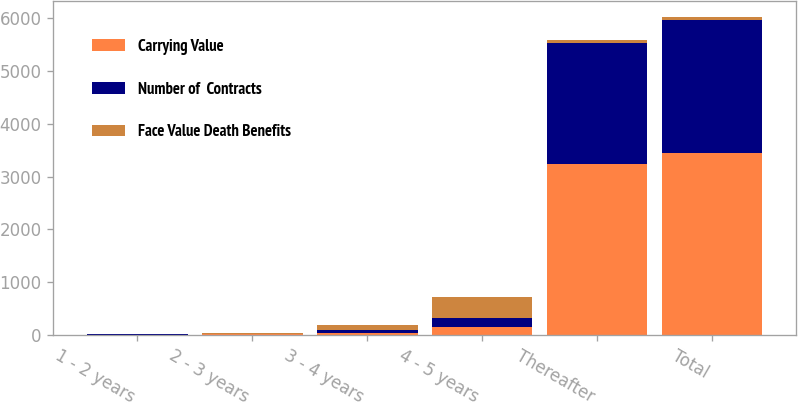Convert chart. <chart><loc_0><loc_0><loc_500><loc_500><stacked_bar_chart><ecel><fcel>1 - 2 years<fcel>2 - 3 years<fcel>3 - 4 years<fcel>4 - 5 years<fcel>Thereafter<fcel>Total<nl><fcel>Carrying Value<fcel>5<fcel>16<fcel>43<fcel>148<fcel>3235<fcel>3448<nl><fcel>Number of  Contracts<fcel>5<fcel>6<fcel>43<fcel>171<fcel>2291<fcel>2516<nl><fcel>Face Value Death Benefits<fcel>10<fcel>14<fcel>93<fcel>404<fcel>68<fcel>68<nl></chart> 